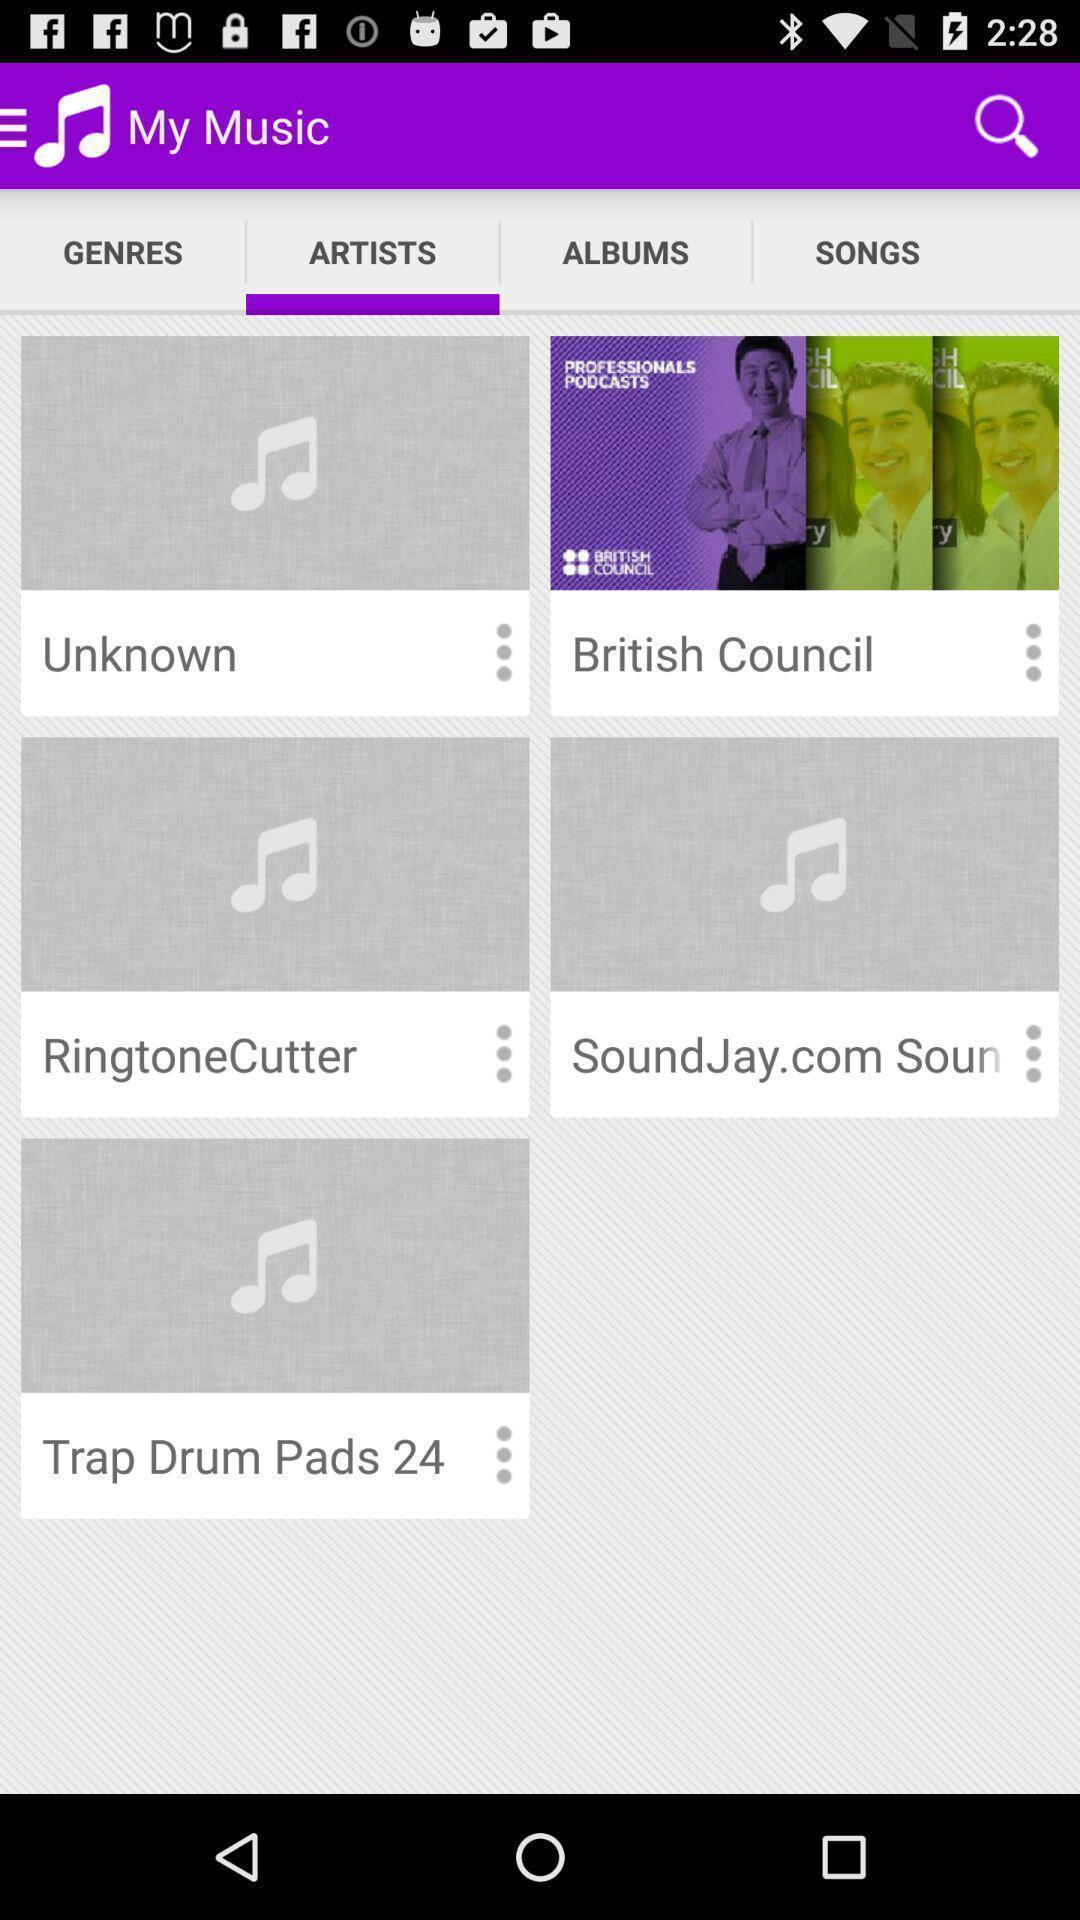Please provide a description for this image. Screen displaying lists of artists. 